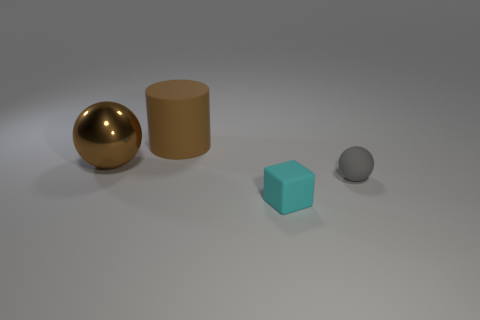Add 2 tiny objects. How many objects exist? 6 Subtract all blocks. How many objects are left? 3 Subtract 1 balls. How many balls are left? 1 Subtract all blue balls. Subtract all cyan blocks. How many balls are left? 2 Subtract all tiny things. Subtract all big matte objects. How many objects are left? 1 Add 2 tiny gray objects. How many tiny gray objects are left? 3 Add 2 large rubber cylinders. How many large rubber cylinders exist? 3 Subtract 0 gray cylinders. How many objects are left? 4 